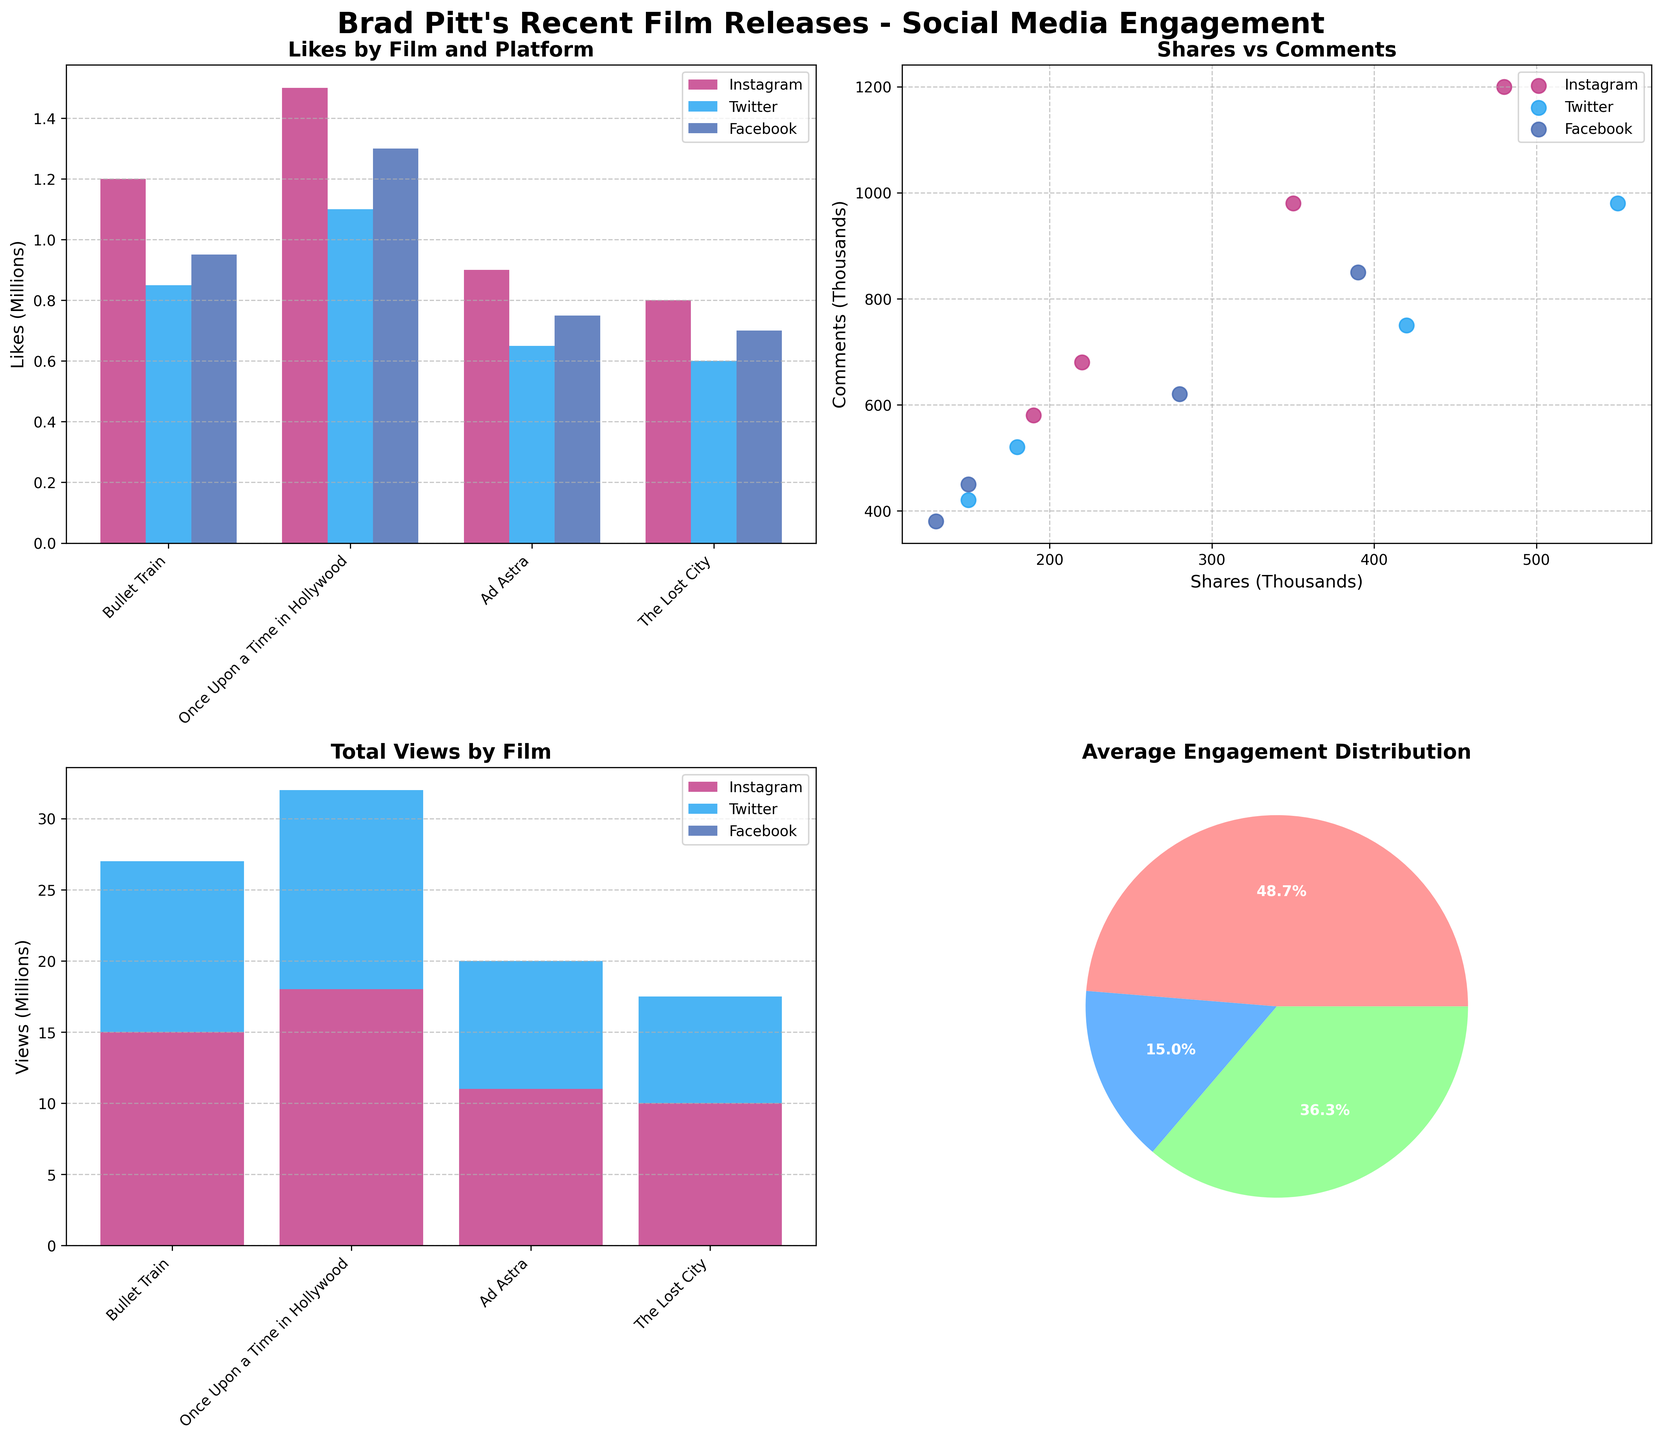what's the title of the figure? The title is usually located at the top of the figure and provides a summary of what the figure represents. In this case, the title is "Brad Pitt's Recent Film Releases - Social Media Engagement."
Answer: Brad Pitt's Recent Film Releases - Social Media Engagement Which film had the most likes on Instagram? Looking at the bar heights in the first subplot, the bar for "Once Upon a Time in Hollywood" on Instagram is the tallest, indicating it had the most likes.
Answer: Once Upon a Time in Hollywood How many comments were there in total for "Bullet Train" across all platforms? You need to sum the comments from Instagram, Twitter, and Facebook for "Bullet Train": 980,000 + 750,000 + 620,000.
Answer: 2,350,000 Which platform has the highest engagement on average? This can be observed from the pie chart showing the average distribution of Likes, Shares, and Comments. The wedges should indicate which engagement type is most frequent.
Answer: Instagram Compare the number of shares for "Ad Astra" on Facebook and Twitter. Which platform has more shares and how many more? From the bar heights in the first subplot for Shares, Facebook shows 150,000 shares whereas Twitter shows 180,000 shares. Taking the difference gives 180,000 - 150,000 = 30,000 shares more on Twitter.
Answer: Twitter, 30,000 What's the least viewed film on Twitter? Refer to the stacked bar chart. "The Lost City" has the shortest bar segment for Twitter.
Answer: The Lost City How does the number of likes on Facebook compare between "Bullet Train" and "Ad Astra"? From the bar heights in the first subplot for Likes, "Bullet Train" had 950,000 likes, and "Ad Astra" had 750,000 likes on Facebook. "Bullet Train" had more likes.
Answer: Bullet Train had more likes For "Once Upon a Time in Hollywood," how do views on Instagram compare to Twitter and Facebook? Observing the stacked bar chart, "Once Upon a Time in Hollywood" has the highest view segment for Instagram compared to Twitter and Facebook. Instagram has more views.
Answer: Instagram has more views What's the overall trend for comments across different platforms? Analyze the scatter plot for Shares vs Comments. Comments tend to increase with shares, but Instagram usually has higher comment counts across comparisons.
Answer: Comments increase with shares, Instagram has higher comments Which engagement type (likes, shares, comments) is the least frequent on average? Looking at the pie chart for average engagement distribution, find the smallest wedge. Typically, shares have the smallest percentage.
Answer: Shares 